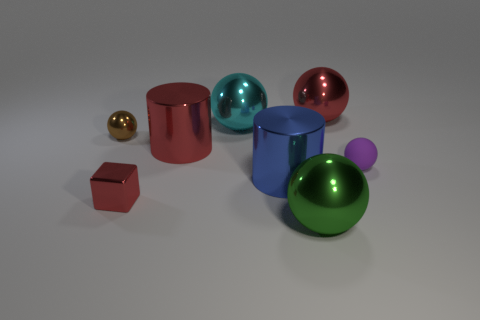Are there any other things that are made of the same material as the red cylinder?
Your answer should be compact. Yes. What size is the sphere on the left side of the large red metal thing that is in front of the brown object?
Your answer should be compact. Small. Does the cyan shiny object have the same size as the green metal sphere?
Ensure brevity in your answer.  Yes. There is a shiny object in front of the tiny metal object that is in front of the matte ball; is there a large red shiny ball that is on the right side of it?
Provide a short and direct response. Yes. What size is the cyan shiny sphere?
Make the answer very short. Large. What number of cyan metal balls have the same size as the red cylinder?
Offer a very short reply. 1. There is a large green object that is the same shape as the small purple thing; what material is it?
Keep it short and to the point. Metal. What is the shape of the small object that is both in front of the large red metal cylinder and left of the small rubber thing?
Give a very brief answer. Cube. What shape is the blue shiny object that is to the right of the block?
Make the answer very short. Cylinder. What number of metal things are both in front of the brown metallic object and right of the big cyan ball?
Offer a very short reply. 2. 